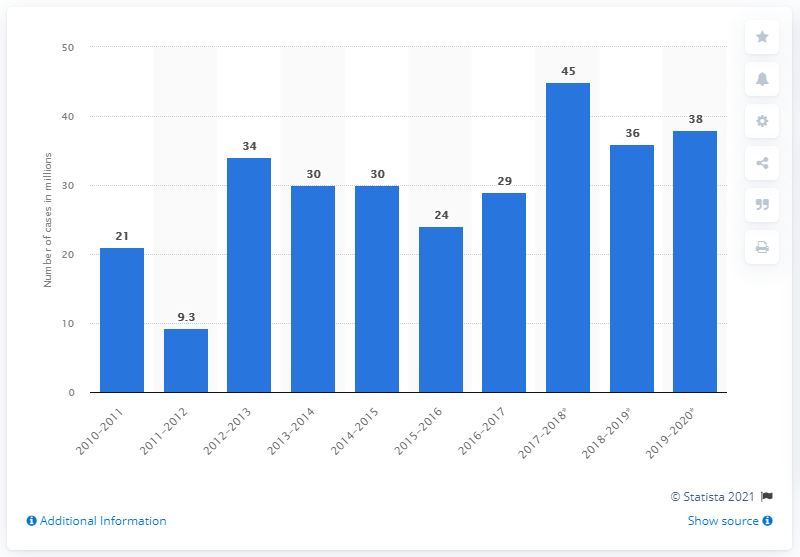Draw attention to some important aspects in this diagram. During the 2019-2020 flu season, there were 38 cases of influenza reported in the United States. 